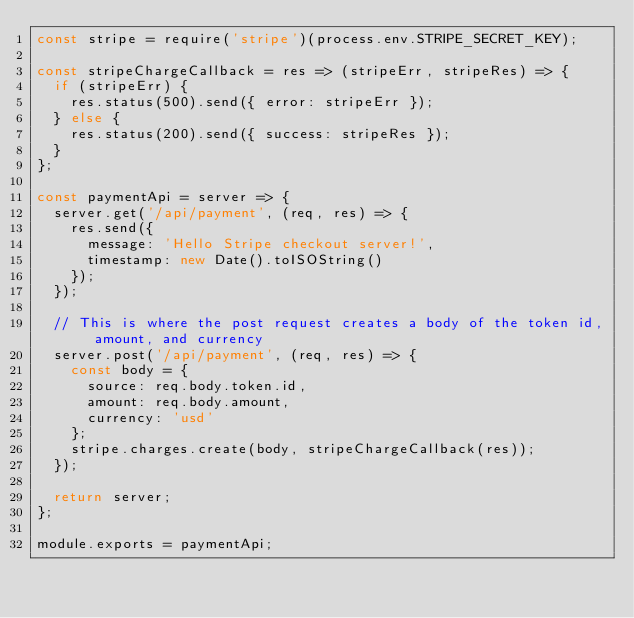<code> <loc_0><loc_0><loc_500><loc_500><_JavaScript_>const stripe = require('stripe')(process.env.STRIPE_SECRET_KEY);

const stripeChargeCallback = res => (stripeErr, stripeRes) => {
  if (stripeErr) {
    res.status(500).send({ error: stripeErr });
  } else {
    res.status(200).send({ success: stripeRes });
  }
};

const paymentApi = server => {
  server.get('/api/payment', (req, res) => {
    res.send({
      message: 'Hello Stripe checkout server!',
      timestamp: new Date().toISOString()
    });
  });

  // This is where the post request creates a body of the token id, amount, and currency
  server.post('/api/payment', (req, res) => {
    const body = {
      source: req.body.token.id,
      amount: req.body.amount,
      currency: 'usd'
    };
    stripe.charges.create(body, stripeChargeCallback(res));
  });

  return server;
};

module.exports = paymentApi;
</code> 